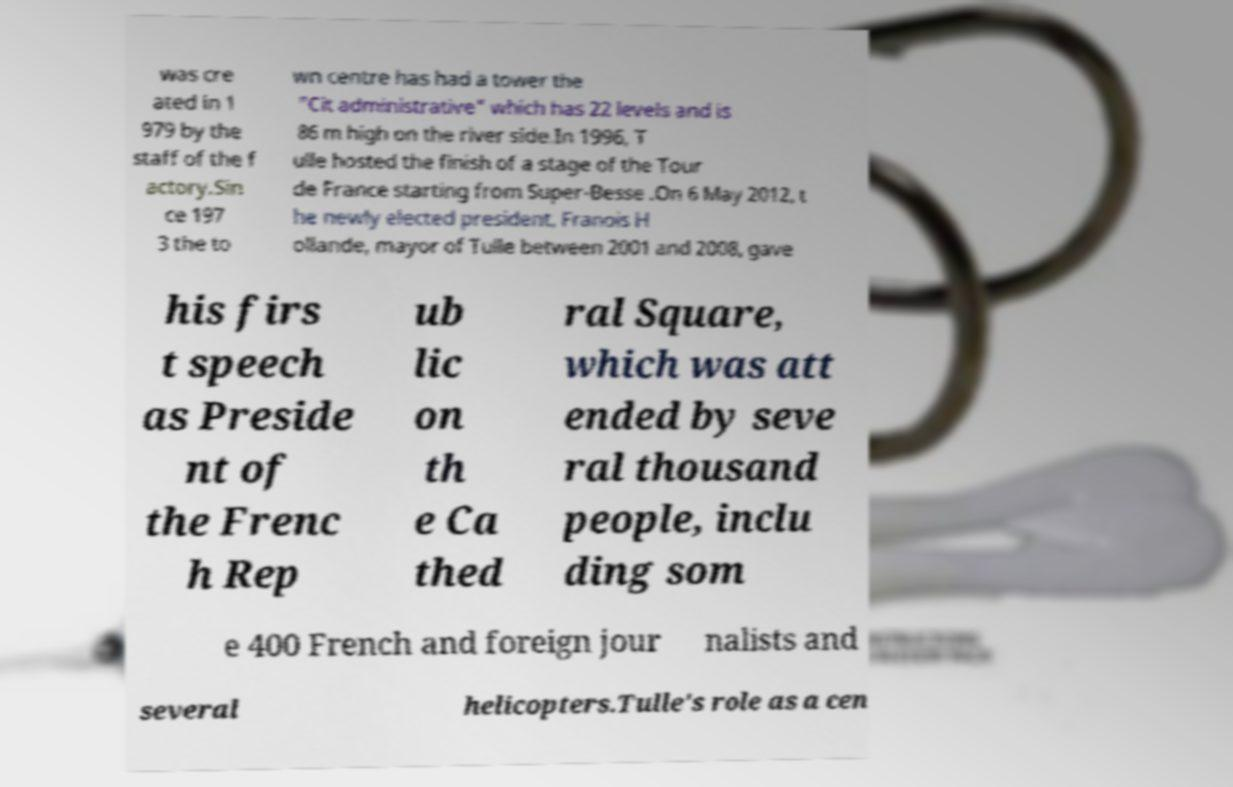Can you accurately transcribe the text from the provided image for me? was cre ated in 1 979 by the staff of the f actory.Sin ce 197 3 the to wn centre has had a tower the "Cit administrative" which has 22 levels and is 86 m high on the river side.In 1996, T ulle hosted the finish of a stage of the Tour de France starting from Super-Besse .On 6 May 2012, t he newly elected president, Franois H ollande, mayor of Tulle between 2001 and 2008, gave his firs t speech as Preside nt of the Frenc h Rep ub lic on th e Ca thed ral Square, which was att ended by seve ral thousand people, inclu ding som e 400 French and foreign jour nalists and several helicopters.Tulle's role as a cen 